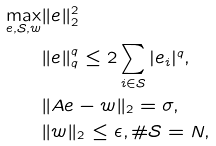<formula> <loc_0><loc_0><loc_500><loc_500>\max _ { e , \mathcal { S } , w } & \| e \| _ { 2 } ^ { 2 } \\ & \| e \| _ { q } ^ { q } \leq 2 \sum _ { i \in \mathcal { S } } | e _ { i } | ^ { q } , \\ & \| { A } e - w \| _ { 2 } = \sigma , \\ & \| w \| _ { 2 } \leq \epsilon , \# \mathcal { S } = N ,</formula> 